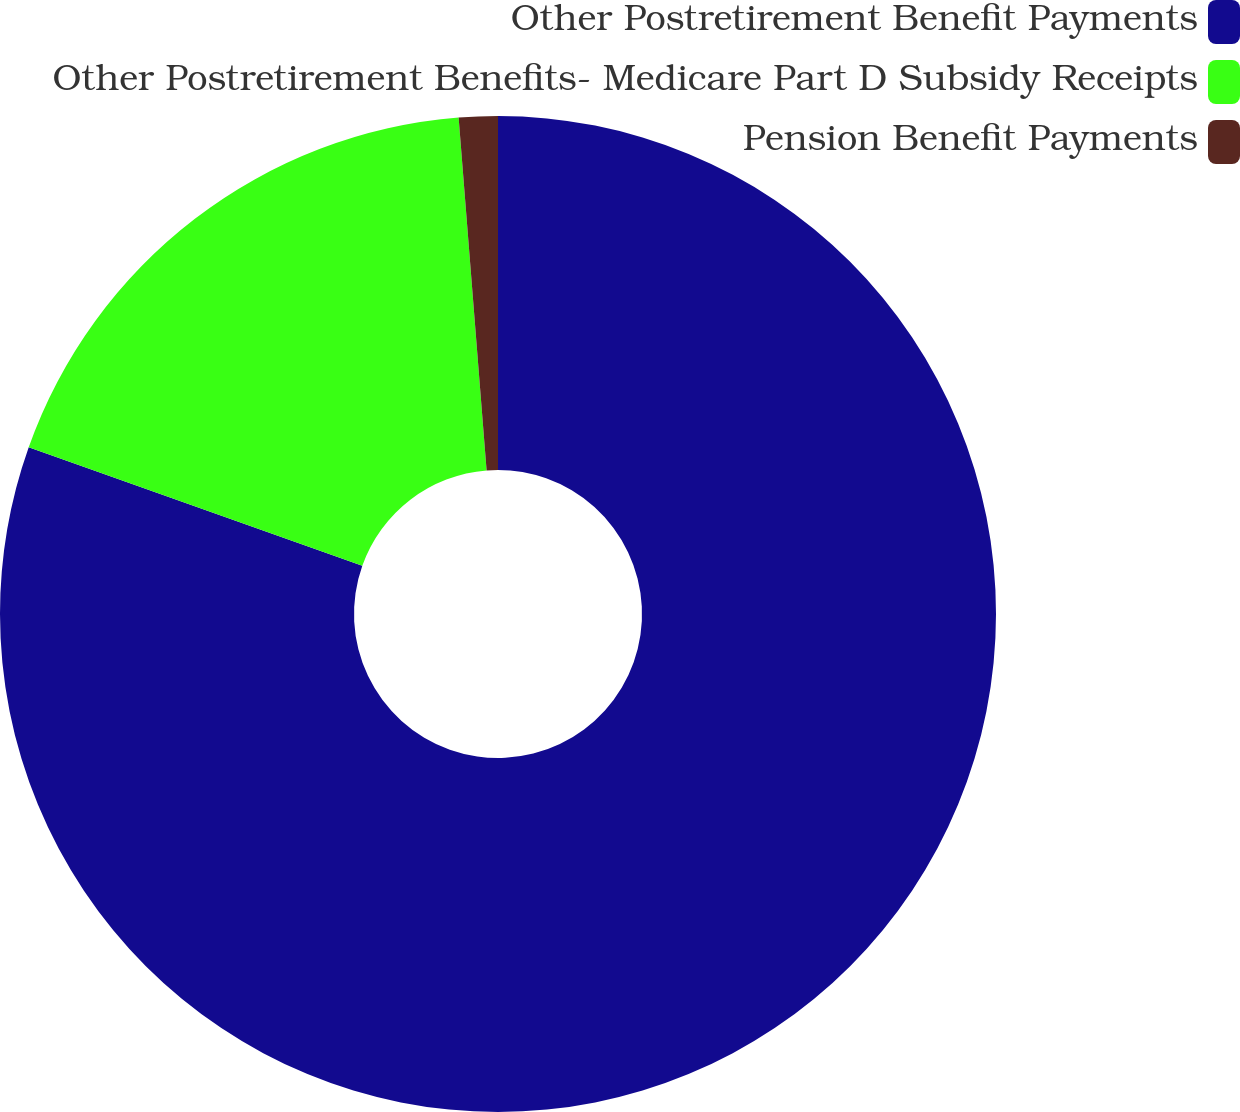Convert chart. <chart><loc_0><loc_0><loc_500><loc_500><pie_chart><fcel>Other Postretirement Benefit Payments<fcel>Other Postretirement Benefits- Medicare Part D Subsidy Receipts<fcel>Pension Benefit Payments<nl><fcel>80.44%<fcel>18.31%<fcel>1.26%<nl></chart> 